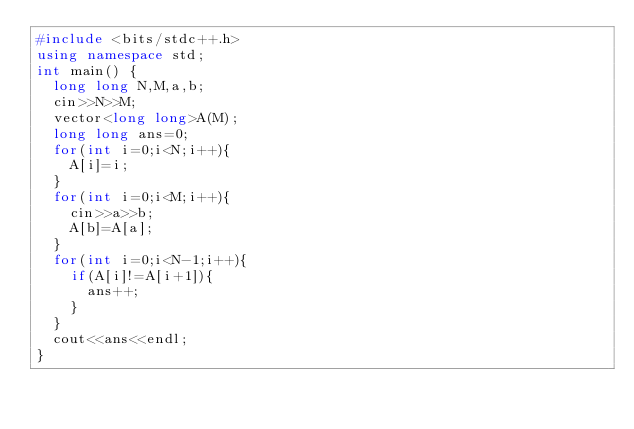Convert code to text. <code><loc_0><loc_0><loc_500><loc_500><_C++_>#include <bits/stdc++.h>
using namespace std;
int main() {
  long long N,M,a,b;
  cin>>N>>M;
  vector<long long>A(M);
  long long ans=0;
  for(int i=0;i<N;i++){
    A[i]=i;
  }
  for(int i=0;i<M;i++){
    cin>>a>>b;
    A[b]=A[a];
  }
  for(int i=0;i<N-1;i++){
    if(A[i]!=A[i+1]){
      ans++;
    }
  }
  cout<<ans<<endl;
}</code> 